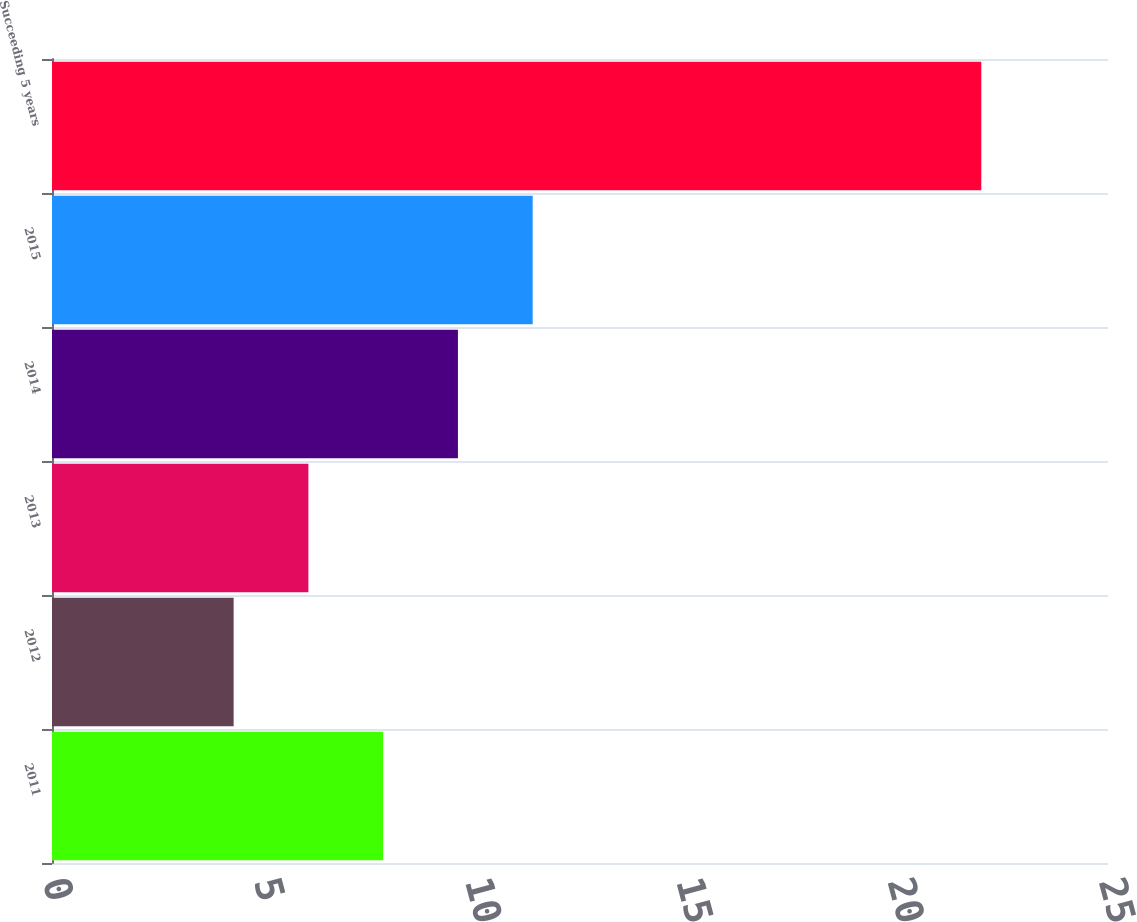Convert chart to OTSL. <chart><loc_0><loc_0><loc_500><loc_500><bar_chart><fcel>2011<fcel>2012<fcel>2013<fcel>2014<fcel>2015<fcel>Succeeding 5 years<nl><fcel>7.84<fcel>4.3<fcel>6.07<fcel>9.61<fcel>11.38<fcel>22<nl></chart> 